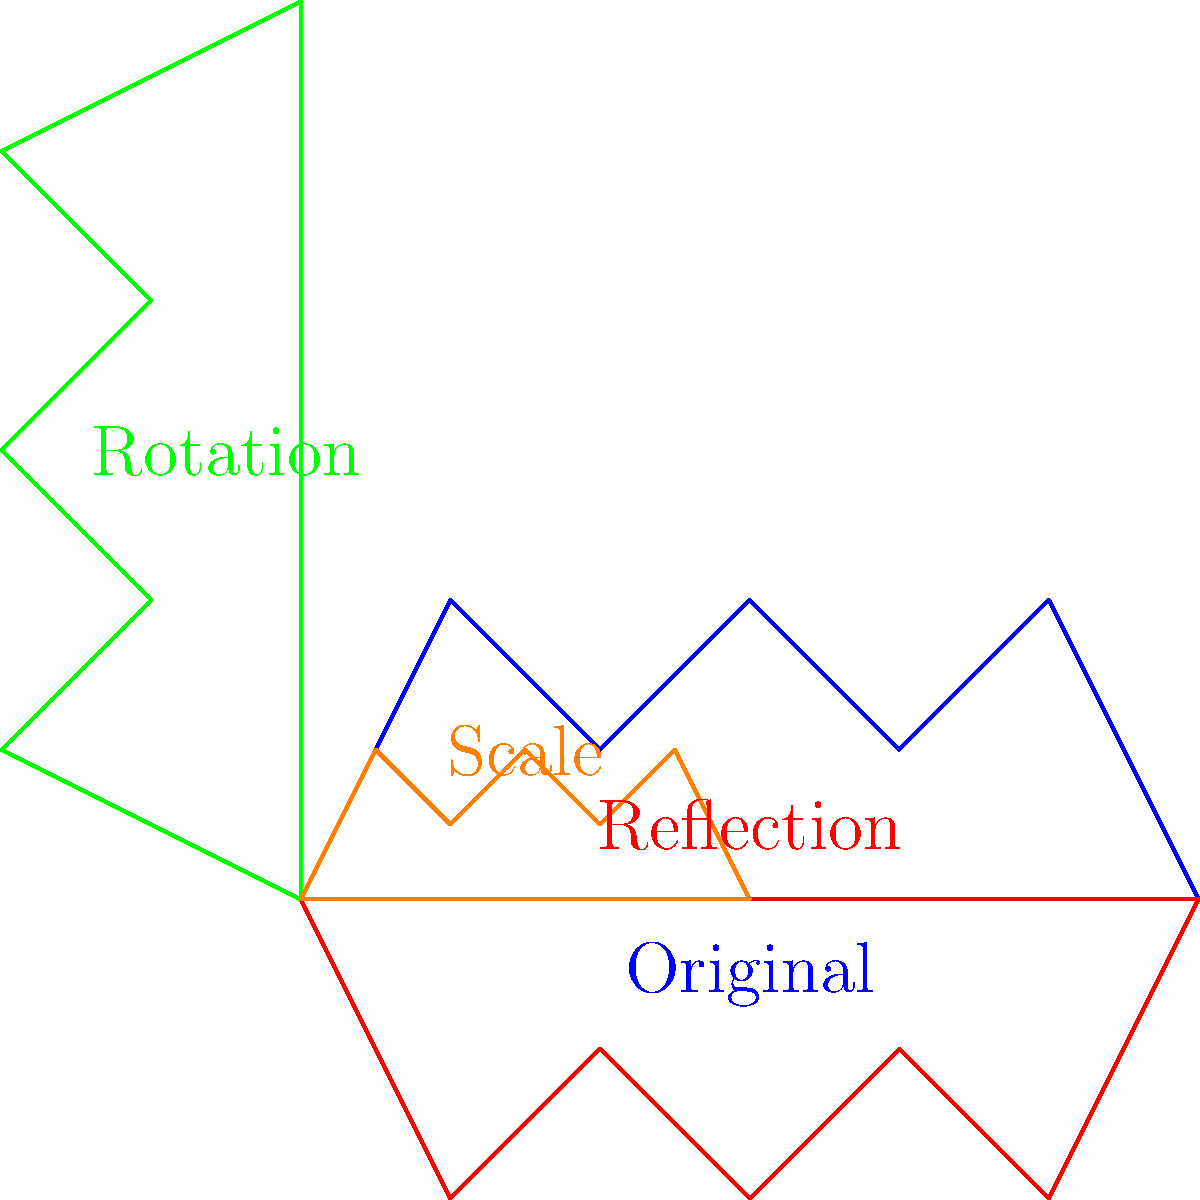A stylized camel silhouette undergoes a series of transformations. The original blue camel is first reflected across the x-axis (red), then rotated 90 degrees counterclockwise (green), and finally scaled by a factor of 0.5 (orange). What is the cumulative transformation matrix that represents all these operations combined? Let's break this down step-by-step:

1) Reflection across the x-axis:
   Matrix: $$R = \begin{pmatrix} 1 & 0 \\ 0 & -1 \end{pmatrix}$$

2) Rotation by 90 degrees counterclockwise:
   Matrix: $$T = \begin{pmatrix} 0 & -1 \\ 1 & 0 \end{pmatrix}$$

3) Scaling by a factor of 0.5:
   Matrix: $$S = \begin{pmatrix} 0.5 & 0 \\ 0 & 0.5 \end{pmatrix}$$

To find the cumulative transformation, we multiply these matrices in the order of application (from right to left):

$$M = S \cdot T \cdot R$$

$$M = \begin{pmatrix} 0.5 & 0 \\ 0 & 0.5 \end{pmatrix} \cdot \begin{pmatrix} 0 & -1 \\ 1 & 0 \end{pmatrix} \cdot \begin{pmatrix} 1 & 0 \\ 0 & -1 \end{pmatrix}$$

$$M = \begin{pmatrix} 0.5 & 0 \\ 0 & 0.5 \end{pmatrix} \cdot \begin{pmatrix} 0 & 1 \\ 1 & 0 \end{pmatrix}$$

$$M = \begin{pmatrix} 0 & 0.5 \\ 0.5 & 0 \end{pmatrix}$$
Answer: $$\begin{pmatrix} 0 & 0.5 \\ 0.5 & 0 \end{pmatrix}$$ 